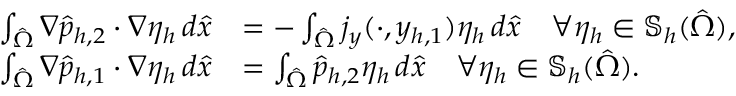<formula> <loc_0><loc_0><loc_500><loc_500>\begin{array} { r l } { \int _ { \hat { \Omega } } \nabla \hat { p } _ { h , 2 } \cdot \nabla \eta _ { h } \, d \hat { x } } & { = - \int _ { \hat { \Omega } } j _ { y } ( \cdot , y _ { h , 1 } ) \eta _ { h } \, d \hat { x } \quad \forall \eta _ { h } \in \mathbb { S } _ { h } ( \hat { \Omega } ) , } \\ { \int _ { \hat { \Omega } } \nabla \hat { p } _ { h , 1 } \cdot \nabla \eta _ { h } \, d \hat { x } } & { = \int _ { \hat { \Omega } } \hat { p } _ { h , 2 } \eta _ { h } \, d \hat { x } \quad \forall \eta _ { h } \in \mathbb { S } _ { h } ( \hat { \Omega } ) . } \end{array}</formula> 